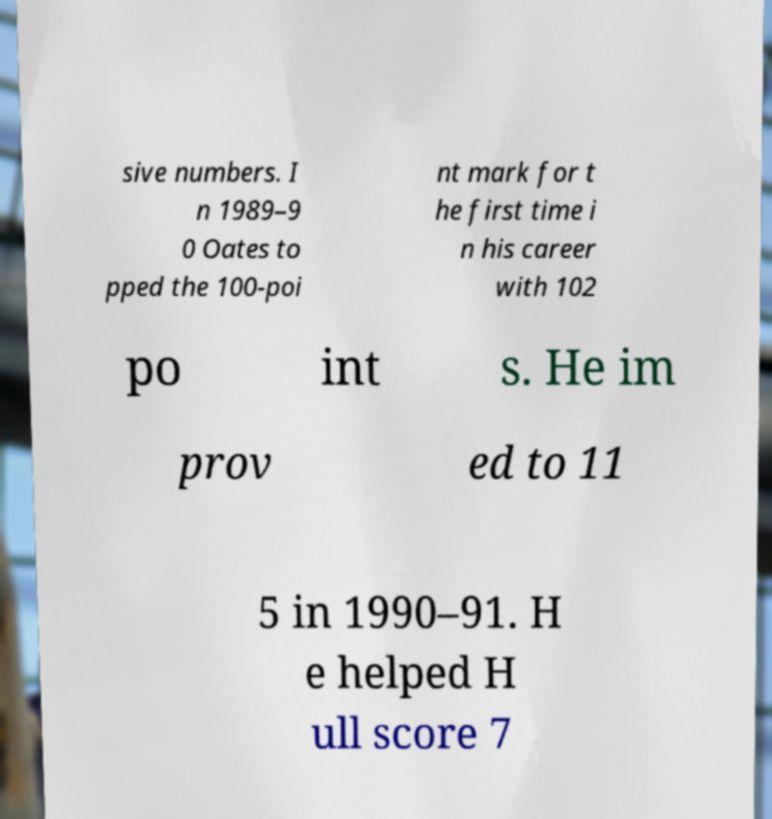Please read and relay the text visible in this image. What does it say? sive numbers. I n 1989–9 0 Oates to pped the 100-poi nt mark for t he first time i n his career with 102 po int s. He im prov ed to 11 5 in 1990–91. H e helped H ull score 7 